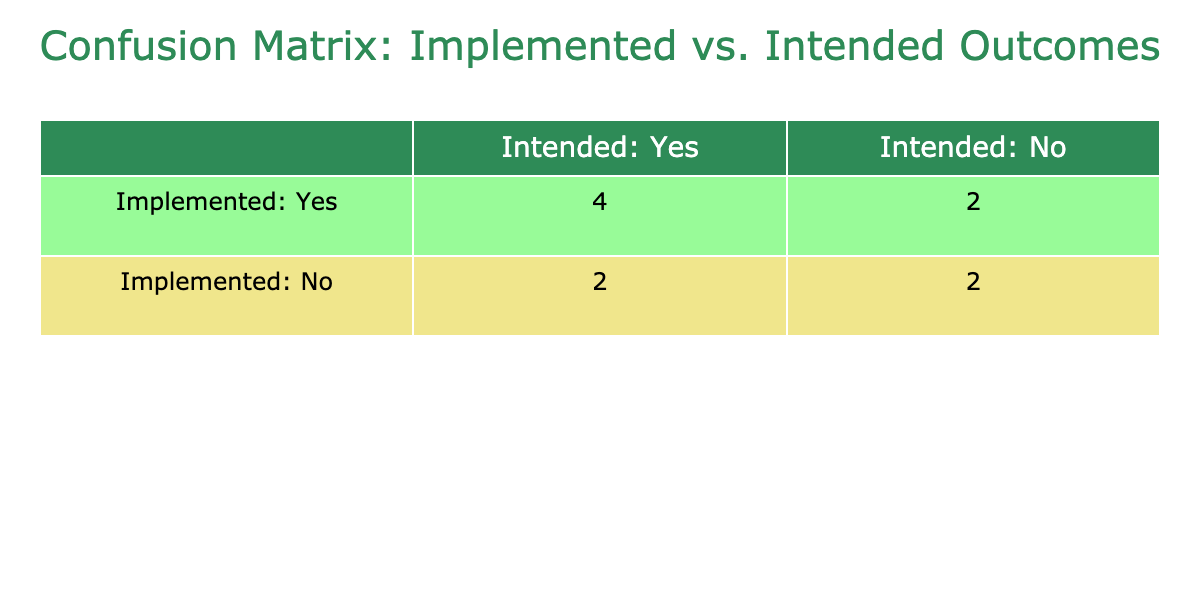What is the number of true positives in the table? The true positives (TP) are the instances where both Implemented Policies and Intended Outcomes are marked as 'Yes'. In the table, these instances are: Sustainable Cities, Biodiversity Conservation, and Reduction of Carbon Emissions, which gives us a total of 3.
Answer: 3 How many false negatives are present in the table? False negatives (FN) occur when Intended Outcomes are 'Yes' but Implemented Policies are 'No'. The instances are Ecological Restoration and Waste Reduction Initiatives, totaling 2.
Answer: 2 What is the total number of cases where Intended Outcomes are 'Yes'? We find the cases where Intended Outcomes are 'Yes' by counting the number of rows with 'Yes' in the Intended Outcomes column. This includes Sustainable Cities, Ecological Restoration, Biodiversity Conservation, Reduction of Carbon Emissions, Waste Reduction Initiatives, and Community Engagement, totaling 6.
Answer: 6 What is the count of instances where Implemented Policies are 'No'? The count of 'No' for Implemented Policies includes Ecological Restoration, Water Resource Management, Waste Reduction Initiatives, Sustainable Agriculture, and Climate Adaptation Strategies, which totals 5 instances.
Answer: 5 Is it true that all Sustainable Cities are also Intended Outcomes? To determine this, we look for Sustainable Cities in the table and check its Intended Outcome value. It is marked as 'Yes' in both Implemented Policies and Intended Outcomes. Therefore, this statement is true.
Answer: Yes How many instances are there where Implemented Policies are 'Yes' but Intended Outcomes are 'No'? This situation defines the false positives (FP). In the table, the only instance is Clean Energy Adoption, giving a count of 1.
Answer: 1 What percentage of implemented policies resulted in intended outcomes being 'Yes'? We calculate this by taking the number of true positives (3) and dividing it by the total of implemented policies (3 true positives + 1 false positive = 4), giving us 3/4 = 0.75 or 75%.
Answer: 75% How many total outcomes are classified as Non-Sustainable (No in Intended Outcomes)? To find this, we count the cases where Intended Outcomes are 'No'. This includes Clean Energy Adoption, Water Resource Management, Climate Adaptation Strategies, and Sustainable Agriculture, totaling 4.
Answer: 4 Is the number of false positives greater than the number of true negatives? False positives (1) versus true negatives (2) need to be compared. Here, false positives are 1 and true negatives are 2, so false positives are not greater. This statement is false.
Answer: No 